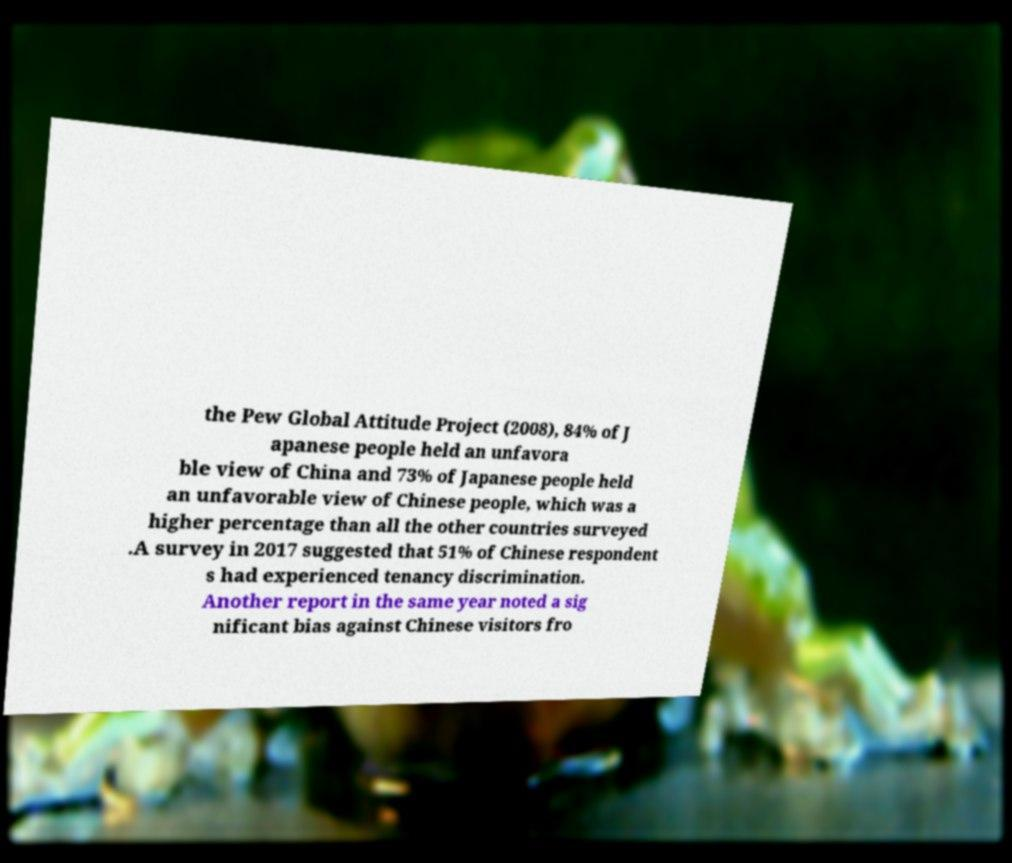Can you read and provide the text displayed in the image?This photo seems to have some interesting text. Can you extract and type it out for me? the Pew Global Attitude Project (2008), 84% of J apanese people held an unfavora ble view of China and 73% of Japanese people held an unfavorable view of Chinese people, which was a higher percentage than all the other countries surveyed .A survey in 2017 suggested that 51% of Chinese respondent s had experienced tenancy discrimination. Another report in the same year noted a sig nificant bias against Chinese visitors fro 